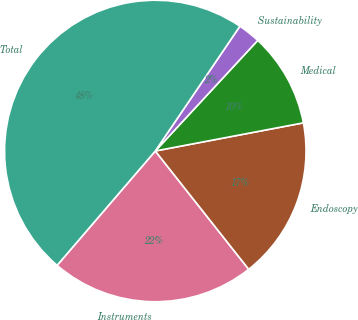<chart> <loc_0><loc_0><loc_500><loc_500><pie_chart><fcel>Instruments<fcel>Endoscopy<fcel>Medical<fcel>Sustainability<fcel>Total<nl><fcel>21.93%<fcel>17.35%<fcel>10.12%<fcel>2.41%<fcel>48.19%<nl></chart> 